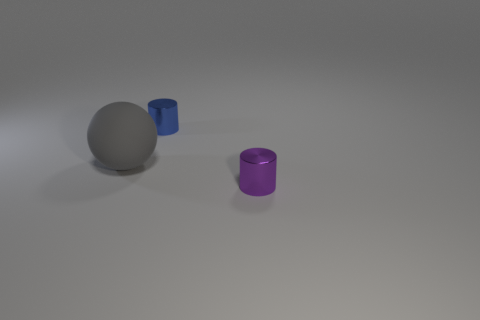What color is the cylinder that is made of the same material as the small blue thing?
Ensure brevity in your answer.  Purple. There is a tiny metal object to the left of the purple metal cylinder; is there a tiny purple cylinder in front of it?
Offer a terse response. Yes. How many other things are the same shape as the big gray thing?
Your answer should be compact. 0. Is the shape of the small metal thing that is behind the large gray thing the same as the object that is on the left side of the blue shiny cylinder?
Give a very brief answer. No. There is a small shiny object that is right of the small shiny cylinder behind the purple cylinder; what number of small blue metal cylinders are behind it?
Give a very brief answer. 1. The matte thing has what color?
Your answer should be very brief. Gray. What number of other objects are the same size as the matte sphere?
Ensure brevity in your answer.  0. What material is the other object that is the same shape as the tiny blue metal thing?
Offer a terse response. Metal. What material is the small thing that is in front of the small shiny cylinder that is behind the tiny metallic cylinder that is in front of the blue cylinder?
Your answer should be very brief. Metal. What is the size of the blue cylinder that is the same material as the tiny purple thing?
Keep it short and to the point. Small. 